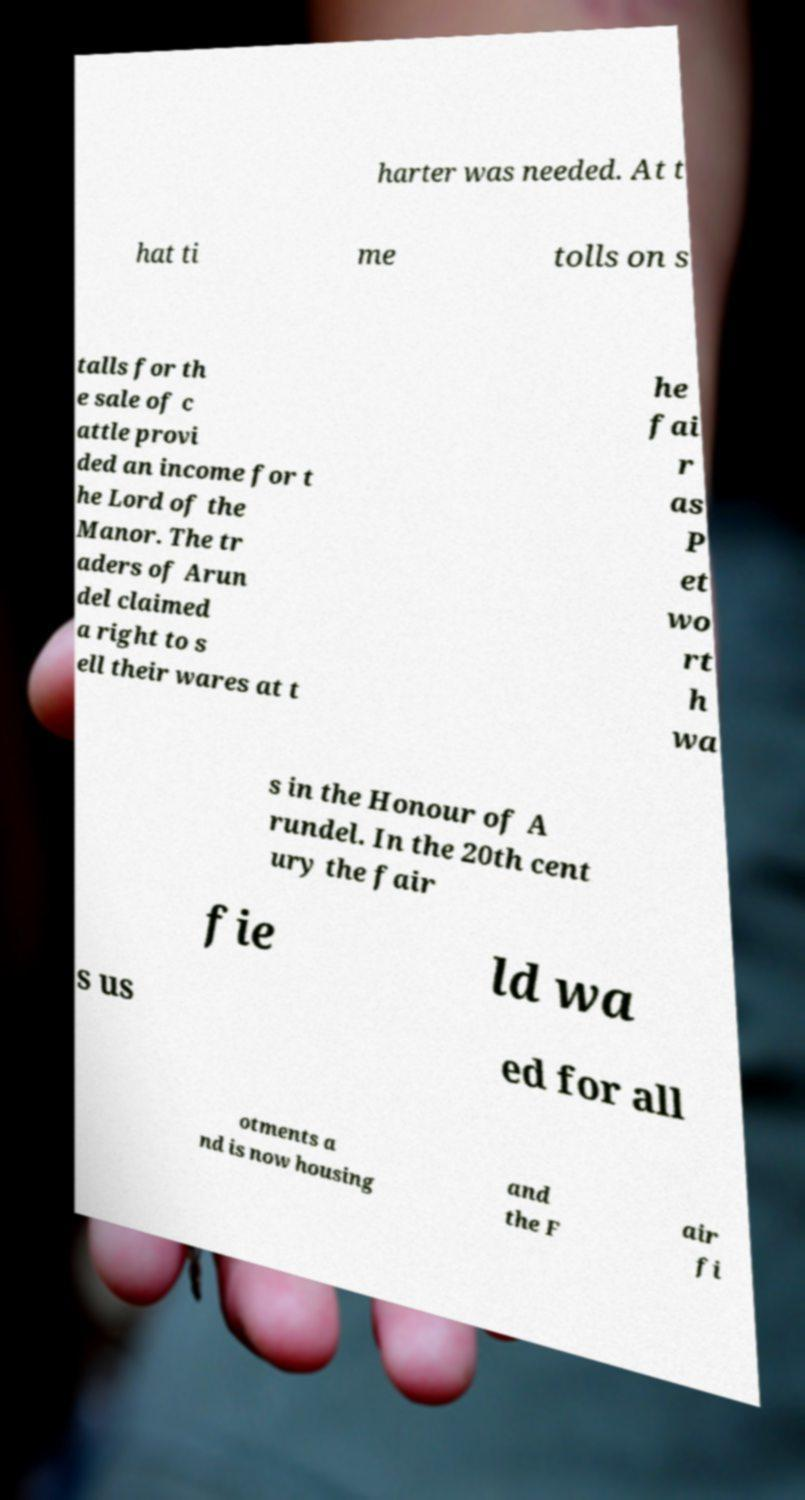What messages or text are displayed in this image? I need them in a readable, typed format. harter was needed. At t hat ti me tolls on s talls for th e sale of c attle provi ded an income for t he Lord of the Manor. The tr aders of Arun del claimed a right to s ell their wares at t he fai r as P et wo rt h wa s in the Honour of A rundel. In the 20th cent ury the fair fie ld wa s us ed for all otments a nd is now housing and the F air fi 